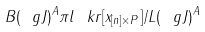Convert formula to latex. <formula><loc_0><loc_0><loc_500><loc_500>B ( \ g J ) ^ { A } \pi l \ k r [ x _ { [ n ] \times P } ] / L ( \ g J ) ^ { A }</formula> 